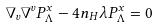<formula> <loc_0><loc_0><loc_500><loc_500>\nabla _ { v } \nabla ^ { v } P _ { \Lambda } ^ { x } - 4 n _ { H } \lambda P _ { \Lambda } ^ { x } = 0</formula> 